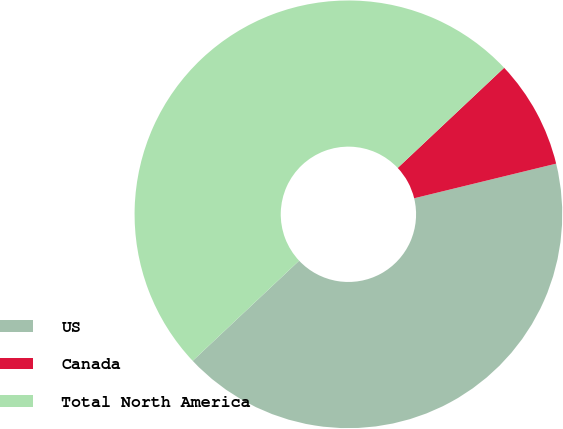Convert chart. <chart><loc_0><loc_0><loc_500><loc_500><pie_chart><fcel>US<fcel>Canada<fcel>Total North America<nl><fcel>41.79%<fcel>8.21%<fcel>50.0%<nl></chart> 